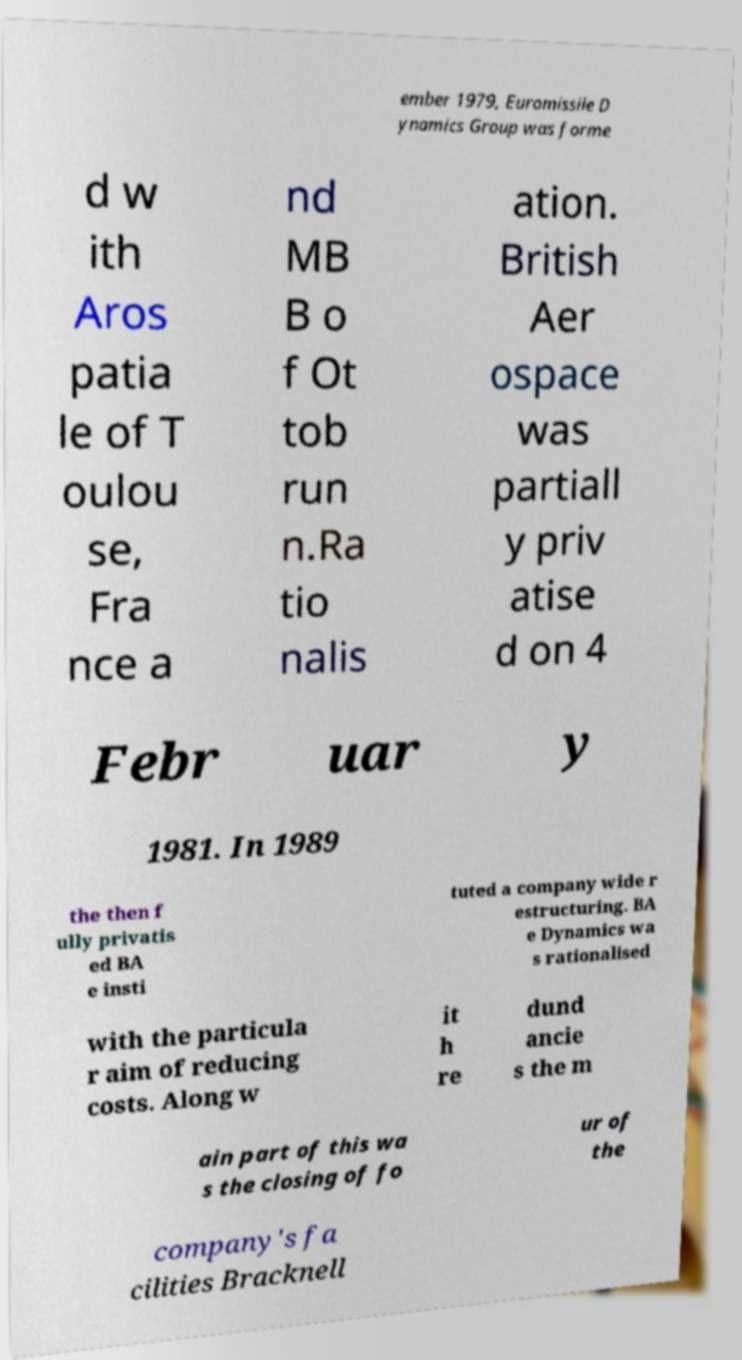Can you accurately transcribe the text from the provided image for me? ember 1979, Euromissile D ynamics Group was forme d w ith Aros patia le of T oulou se, Fra nce a nd MB B o f Ot tob run n.Ra tio nalis ation. British Aer ospace was partiall y priv atise d on 4 Febr uar y 1981. In 1989 the then f ully privatis ed BA e insti tuted a company wide r estructuring. BA e Dynamics wa s rationalised with the particula r aim of reducing costs. Along w it h re dund ancie s the m ain part of this wa s the closing of fo ur of the company's fa cilities Bracknell 